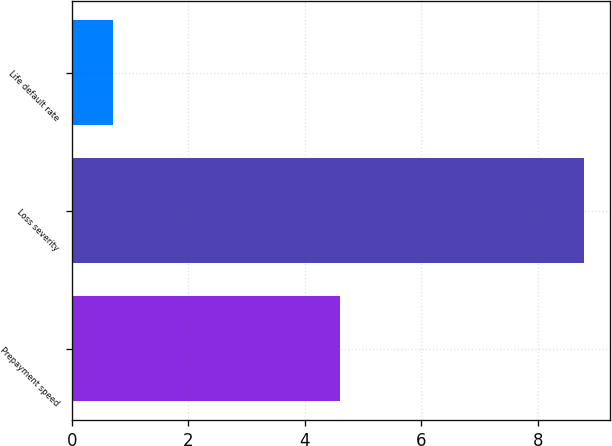Convert chart. <chart><loc_0><loc_0><loc_500><loc_500><bar_chart><fcel>Prepayment speed<fcel>Loss severity<fcel>Life default rate<nl><fcel>4.6<fcel>8.8<fcel>0.7<nl></chart> 